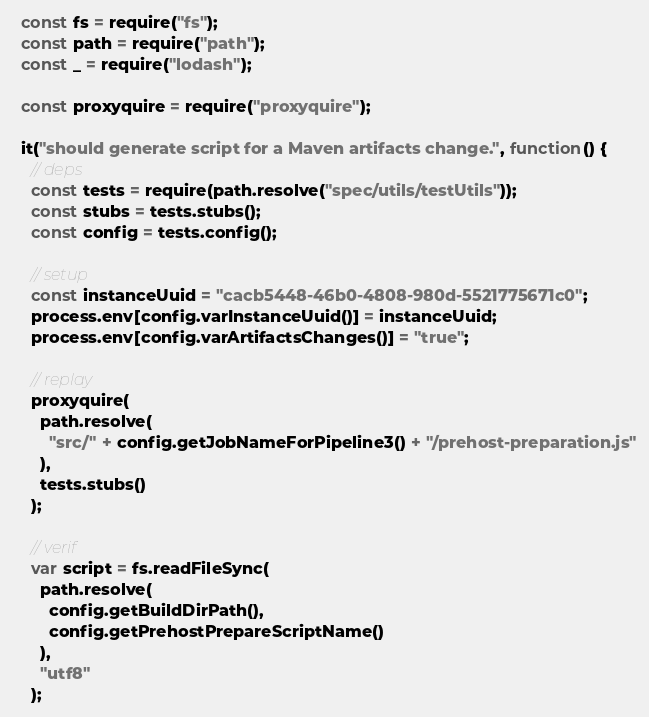Convert code to text. <code><loc_0><loc_0><loc_500><loc_500><_JavaScript_>  const fs = require("fs");
  const path = require("path");
  const _ = require("lodash");

  const proxyquire = require("proxyquire");

  it("should generate script for a Maven artifacts change.", function() {
    // deps
    const tests = require(path.resolve("spec/utils/testUtils"));
    const stubs = tests.stubs();
    const config = tests.config();

    // setup
    const instanceUuid = "cacb5448-46b0-4808-980d-5521775671c0";
    process.env[config.varInstanceUuid()] = instanceUuid;
    process.env[config.varArtifactsChanges()] = "true";

    // replay
    proxyquire(
      path.resolve(
        "src/" + config.getJobNameForPipeline3() + "/prehost-preparation.js"
      ),
      tests.stubs()
    );

    // verif
    var script = fs.readFileSync(
      path.resolve(
        config.getBuildDirPath(),
        config.getPrehostPrepareScriptName()
      ),
      "utf8"
    );</code> 